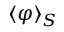Convert formula to latex. <formula><loc_0><loc_0><loc_500><loc_500>\langle \varphi \rangle _ { S }</formula> 